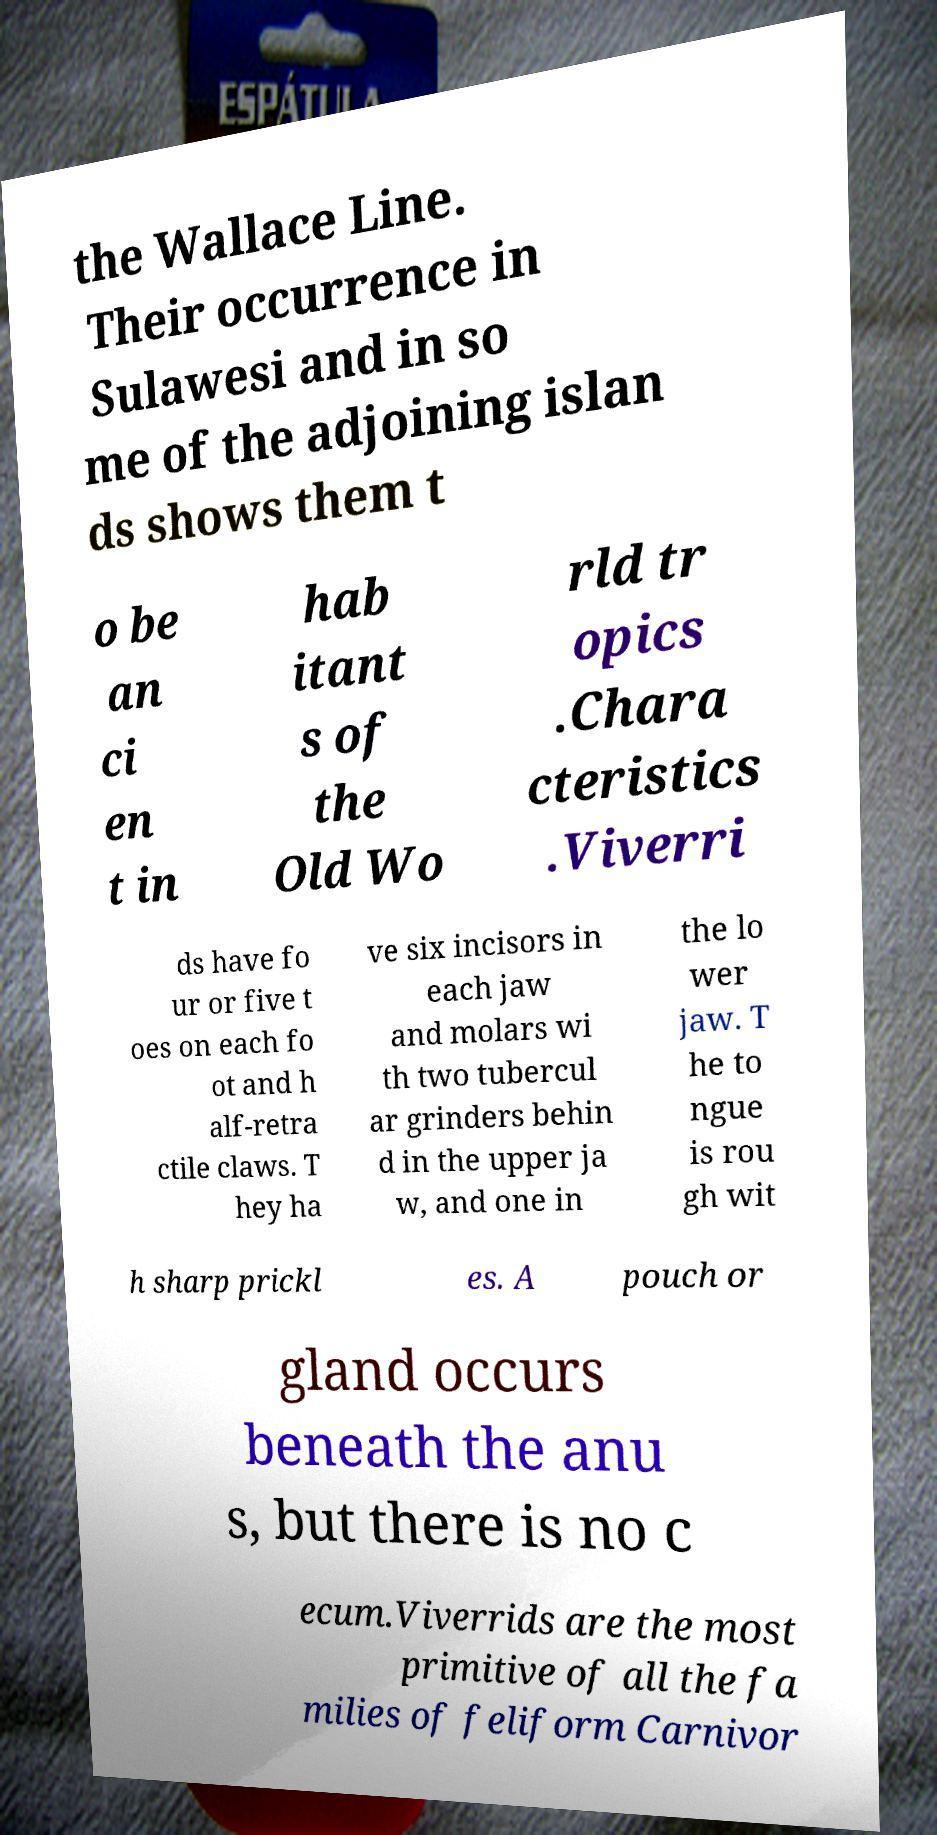Could you assist in decoding the text presented in this image and type it out clearly? the Wallace Line. Their occurrence in Sulawesi and in so me of the adjoining islan ds shows them t o be an ci en t in hab itant s of the Old Wo rld tr opics .Chara cteristics .Viverri ds have fo ur or five t oes on each fo ot and h alf-retra ctile claws. T hey ha ve six incisors in each jaw and molars wi th two tubercul ar grinders behin d in the upper ja w, and one in the lo wer jaw. T he to ngue is rou gh wit h sharp prickl es. A pouch or gland occurs beneath the anu s, but there is no c ecum.Viverrids are the most primitive of all the fa milies of feliform Carnivor 